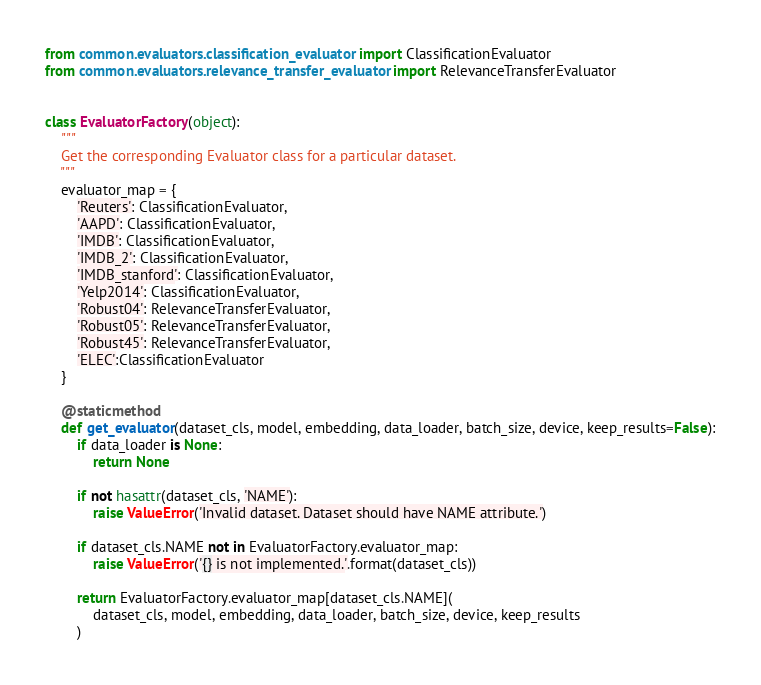<code> <loc_0><loc_0><loc_500><loc_500><_Python_>from common.evaluators.classification_evaluator import ClassificationEvaluator
from common.evaluators.relevance_transfer_evaluator import RelevanceTransferEvaluator


class EvaluatorFactory(object):
    """
    Get the corresponding Evaluator class for a particular dataset.
    """
    evaluator_map = {
        'Reuters': ClassificationEvaluator,
        'AAPD': ClassificationEvaluator,
        'IMDB': ClassificationEvaluator,
        'IMDB_2': ClassificationEvaluator,
        'IMDB_stanford': ClassificationEvaluator,
        'Yelp2014': ClassificationEvaluator,
        'Robust04': RelevanceTransferEvaluator,
        'Robust05': RelevanceTransferEvaluator,
        'Robust45': RelevanceTransferEvaluator,
        'ELEC':ClassificationEvaluator
    }

    @staticmethod
    def get_evaluator(dataset_cls, model, embedding, data_loader, batch_size, device, keep_results=False):
        if data_loader is None:
            return None

        if not hasattr(dataset_cls, 'NAME'):
            raise ValueError('Invalid dataset. Dataset should have NAME attribute.')

        if dataset_cls.NAME not in EvaluatorFactory.evaluator_map:
            raise ValueError('{} is not implemented.'.format(dataset_cls))

        return EvaluatorFactory.evaluator_map[dataset_cls.NAME](
            dataset_cls, model, embedding, data_loader, batch_size, device, keep_results
        )
</code> 